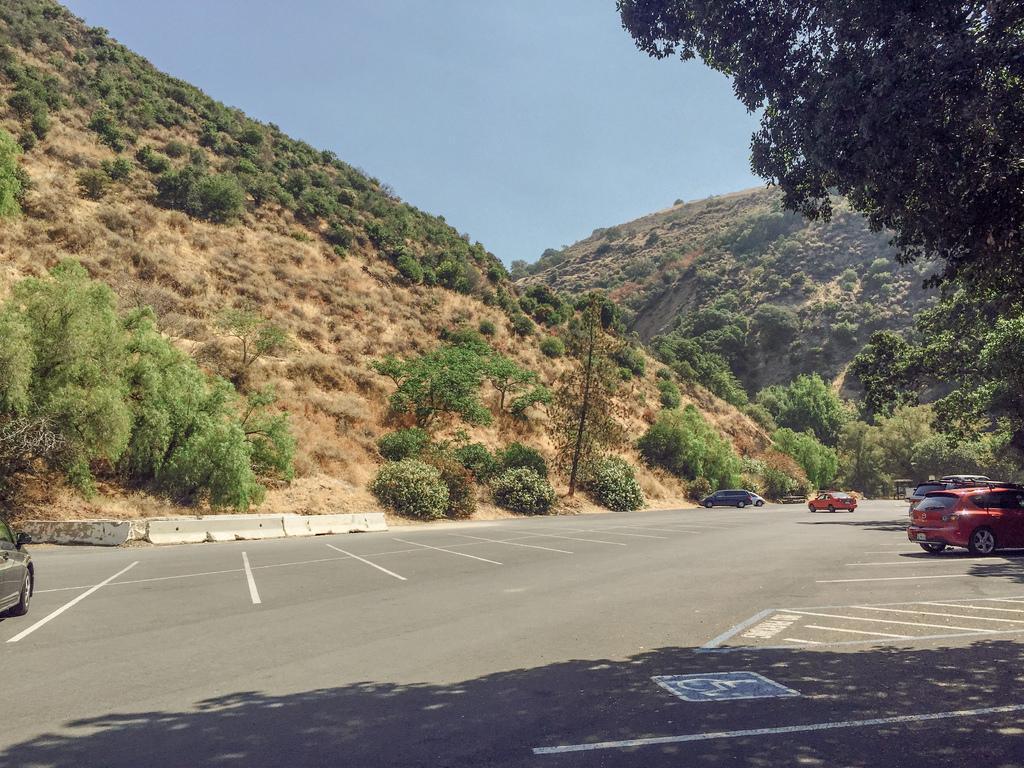Describe this image in one or two sentences. In this image in front there are cars on the road. In the background of the image there are trees and sky. 